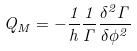Convert formula to latex. <formula><loc_0><loc_0><loc_500><loc_500>Q _ { M } = - \frac { 1 } { h } \frac { 1 } { \Gamma } \frac { \delta ^ { 2 } \Gamma } { \delta \phi ^ { 2 } }</formula> 